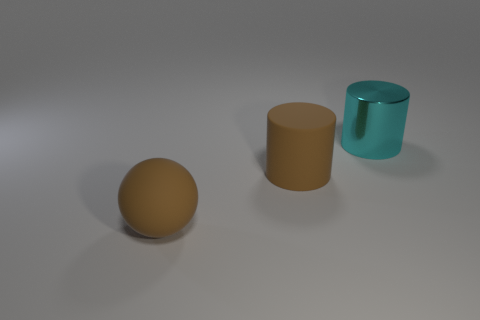There is a matte thing to the right of the large brown sphere; does it have the same color as the ball?
Ensure brevity in your answer.  Yes. How many large things are behind the brown rubber ball and in front of the shiny thing?
Provide a short and direct response. 1. How many other things are the same material as the big cyan cylinder?
Make the answer very short. 0. Does the cylinder that is on the left side of the cyan shiny cylinder have the same material as the large brown ball?
Provide a succinct answer. Yes. There is a cylinder that is in front of the big object that is to the right of the rubber thing that is to the right of the matte ball; how big is it?
Give a very brief answer. Large. What number of other things are the same color as the large rubber ball?
Keep it short and to the point. 1. What shape is the rubber object that is the same size as the matte cylinder?
Your response must be concise. Sphere. How big is the thing that is in front of the large matte cylinder?
Your response must be concise. Large. Is the color of the cylinder that is in front of the large cyan cylinder the same as the big object in front of the big brown cylinder?
Offer a very short reply. Yes. What is the material of the brown thing behind the brown rubber object that is in front of the big cylinder that is on the left side of the big cyan metal object?
Provide a short and direct response. Rubber. 